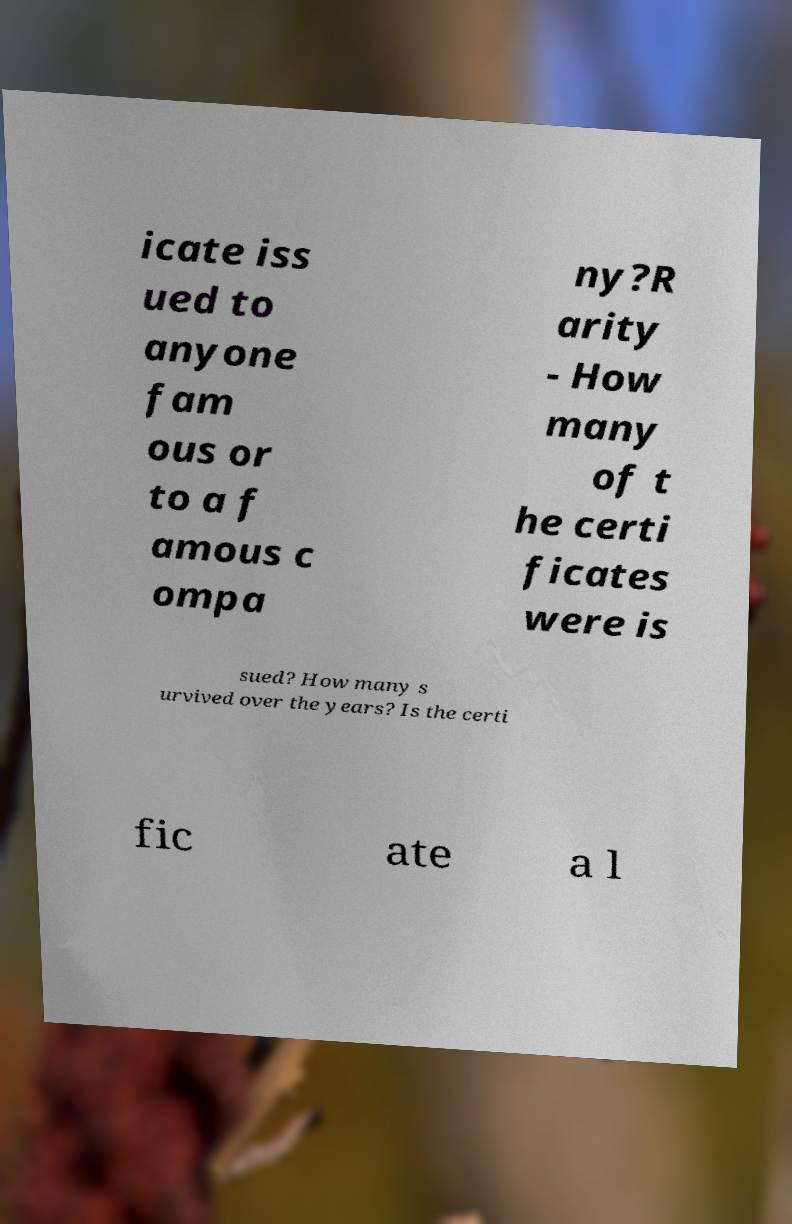There's text embedded in this image that I need extracted. Can you transcribe it verbatim? icate iss ued to anyone fam ous or to a f amous c ompa ny?R arity - How many of t he certi ficates were is sued? How many s urvived over the years? Is the certi fic ate a l 